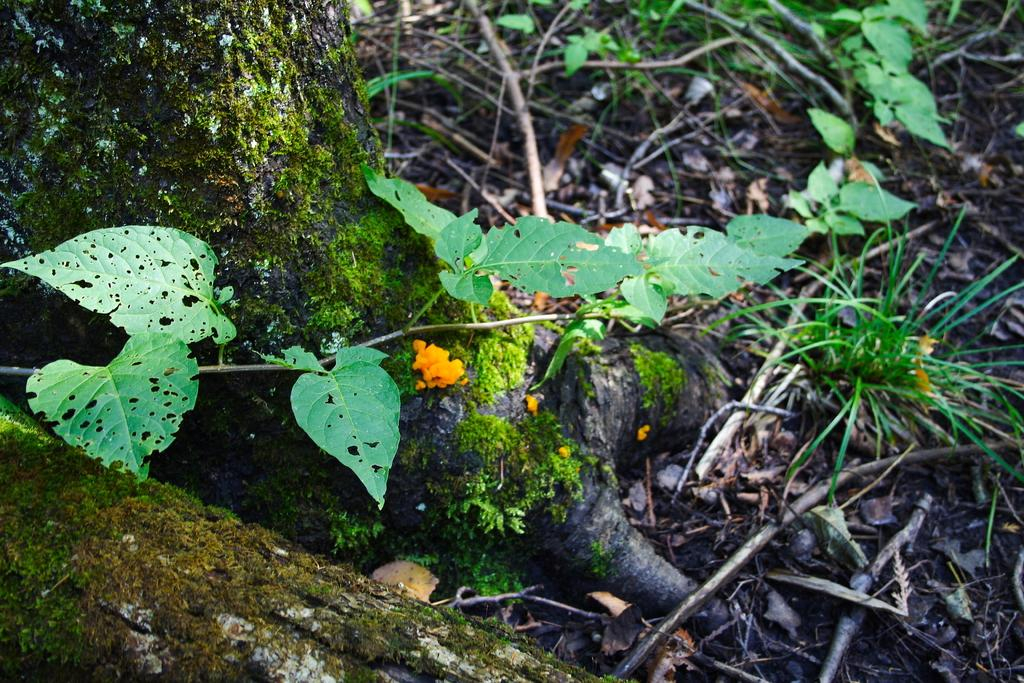What part of a tree is visible in the image? The trunk of a tree is visible in the image. What else can be seen on the tree in the image? There are leaves and branches in the image. How many mittens are hanging from the branches in the image? There are no mittens present in the image; it features a tree with leaves and branches. 